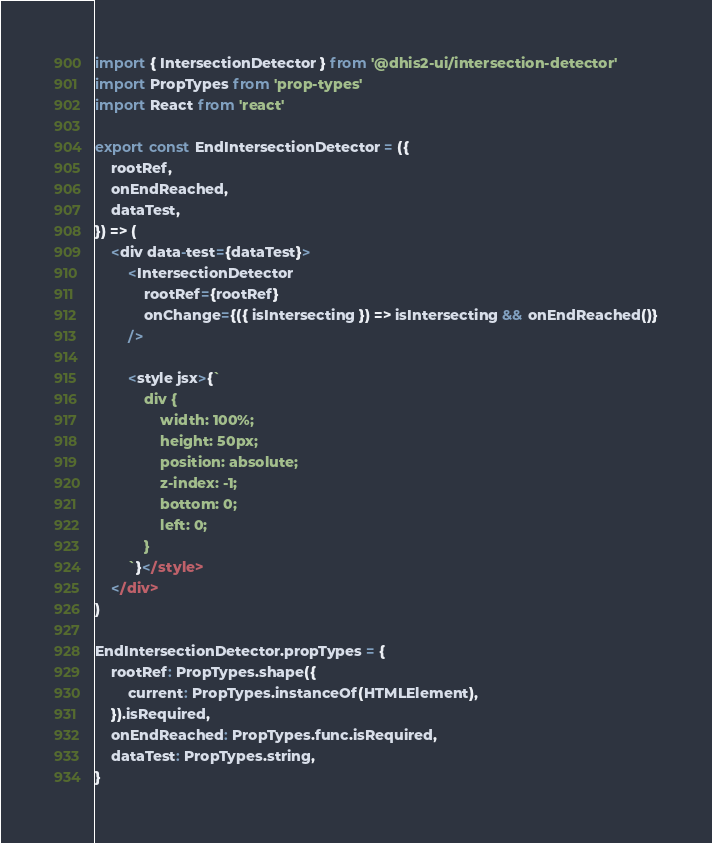Convert code to text. <code><loc_0><loc_0><loc_500><loc_500><_JavaScript_>import { IntersectionDetector } from '@dhis2-ui/intersection-detector'
import PropTypes from 'prop-types'
import React from 'react'

export const EndIntersectionDetector = ({
    rootRef,
    onEndReached,
    dataTest,
}) => (
    <div data-test={dataTest}>
        <IntersectionDetector
            rootRef={rootRef}
            onChange={({ isIntersecting }) => isIntersecting && onEndReached()}
        />

        <style jsx>{`
            div {
                width: 100%;
                height: 50px;
                position: absolute;
                z-index: -1;
                bottom: 0;
                left: 0;
            }
        `}</style>
    </div>
)

EndIntersectionDetector.propTypes = {
    rootRef: PropTypes.shape({
        current: PropTypes.instanceOf(HTMLElement),
    }).isRequired,
    onEndReached: PropTypes.func.isRequired,
    dataTest: PropTypes.string,
}
</code> 